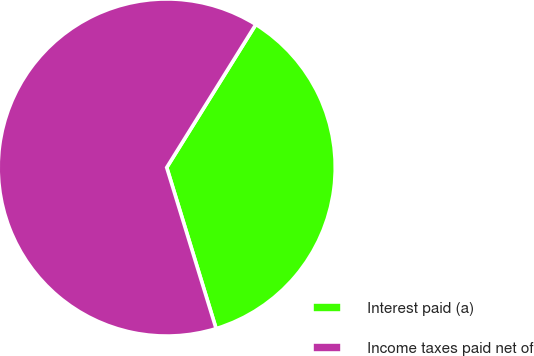<chart> <loc_0><loc_0><loc_500><loc_500><pie_chart><fcel>Interest paid (a)<fcel>Income taxes paid net of<nl><fcel>36.4%<fcel>63.6%<nl></chart> 